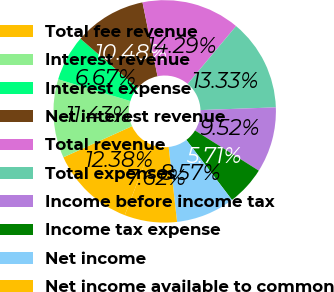Convert chart. <chart><loc_0><loc_0><loc_500><loc_500><pie_chart><fcel>Total fee revenue<fcel>Interest revenue<fcel>Interest expense<fcel>Net interest revenue<fcel>Total revenue<fcel>Total expenses<fcel>Income before income tax<fcel>Income tax expense<fcel>Net income<fcel>Net income available to common<nl><fcel>12.38%<fcel>11.43%<fcel>6.67%<fcel>10.48%<fcel>14.29%<fcel>13.33%<fcel>9.52%<fcel>5.71%<fcel>8.57%<fcel>7.62%<nl></chart> 